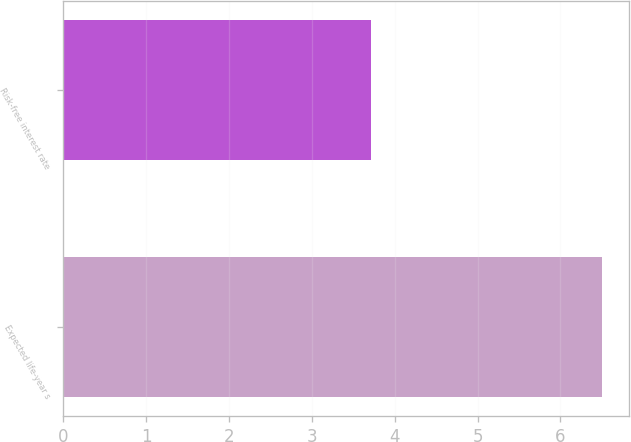Convert chart. <chart><loc_0><loc_0><loc_500><loc_500><bar_chart><fcel>Expected life-year s<fcel>Risk-free interest rate<nl><fcel>6.5<fcel>3.71<nl></chart> 